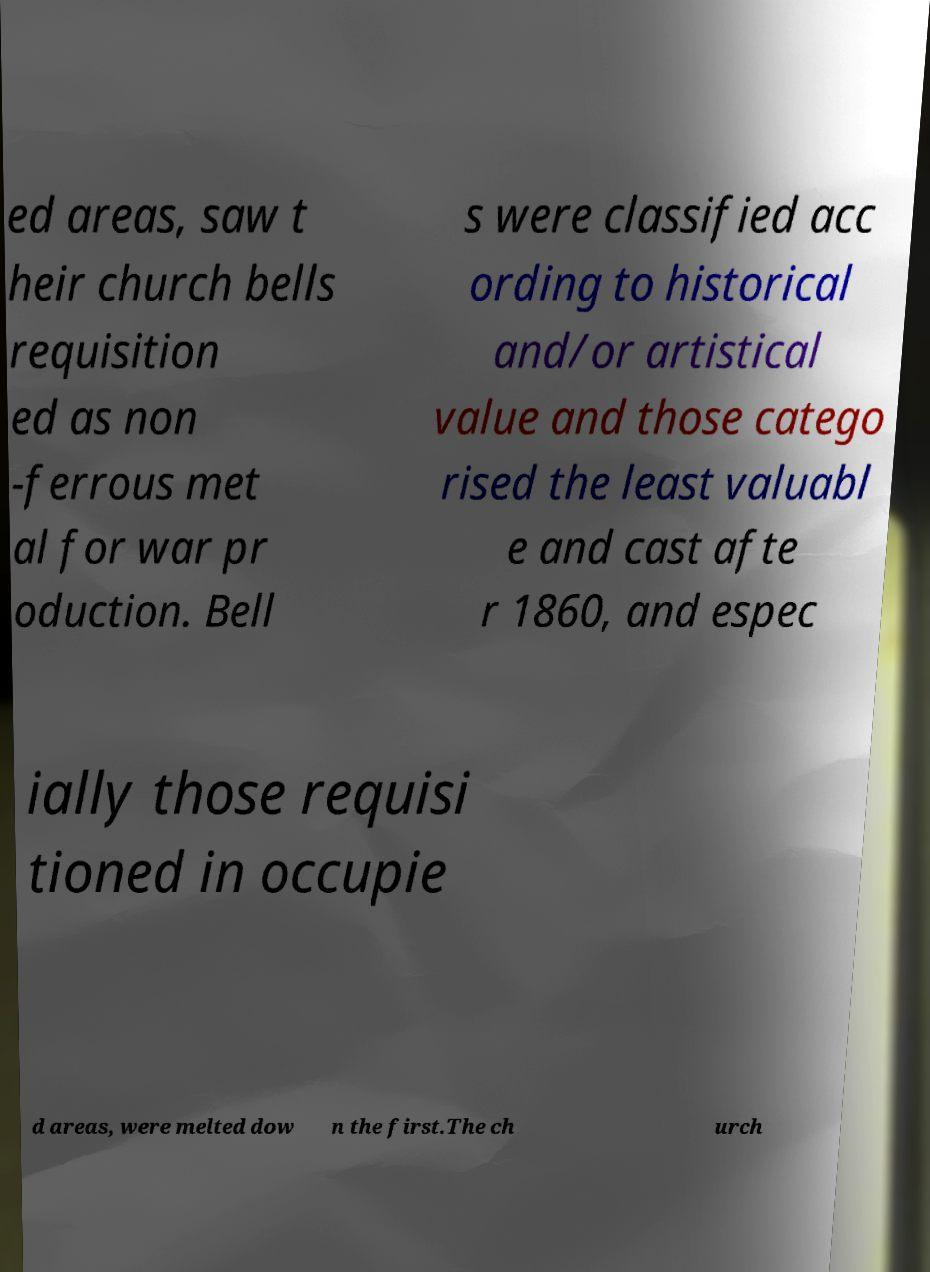I need the written content from this picture converted into text. Can you do that? ed areas, saw t heir church bells requisition ed as non -ferrous met al for war pr oduction. Bell s were classified acc ording to historical and/or artistical value and those catego rised the least valuabl e and cast afte r 1860, and espec ially those requisi tioned in occupie d areas, were melted dow n the first.The ch urch 